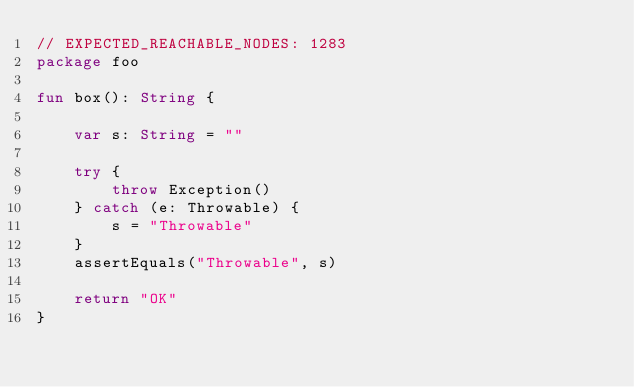<code> <loc_0><loc_0><loc_500><loc_500><_Kotlin_>// EXPECTED_REACHABLE_NODES: 1283
package foo

fun box(): String {

    var s: String = ""

    try {
        throw Exception()
    } catch (e: Throwable) {
        s = "Throwable"
    }
    assertEquals("Throwable", s)

    return "OK"
}</code> 